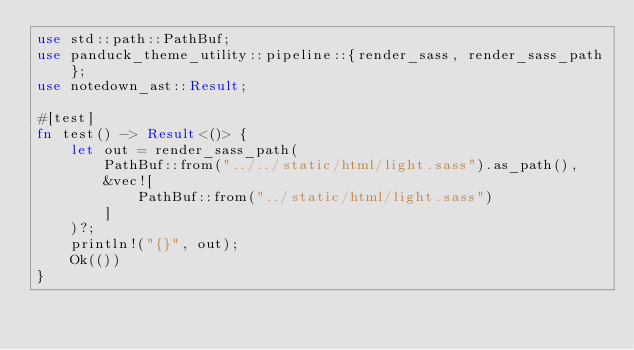Convert code to text. <code><loc_0><loc_0><loc_500><loc_500><_Rust_>use std::path::PathBuf;
use panduck_theme_utility::pipeline::{render_sass, render_sass_path};
use notedown_ast::Result;

#[test]
fn test() -> Result<()> {
    let out = render_sass_path(
        PathBuf::from("../../static/html/light.sass").as_path(),
        &vec![
            PathBuf::from("../static/html/light.sass")
        ]
    )?;
    println!("{}", out);
    Ok(())
}</code> 